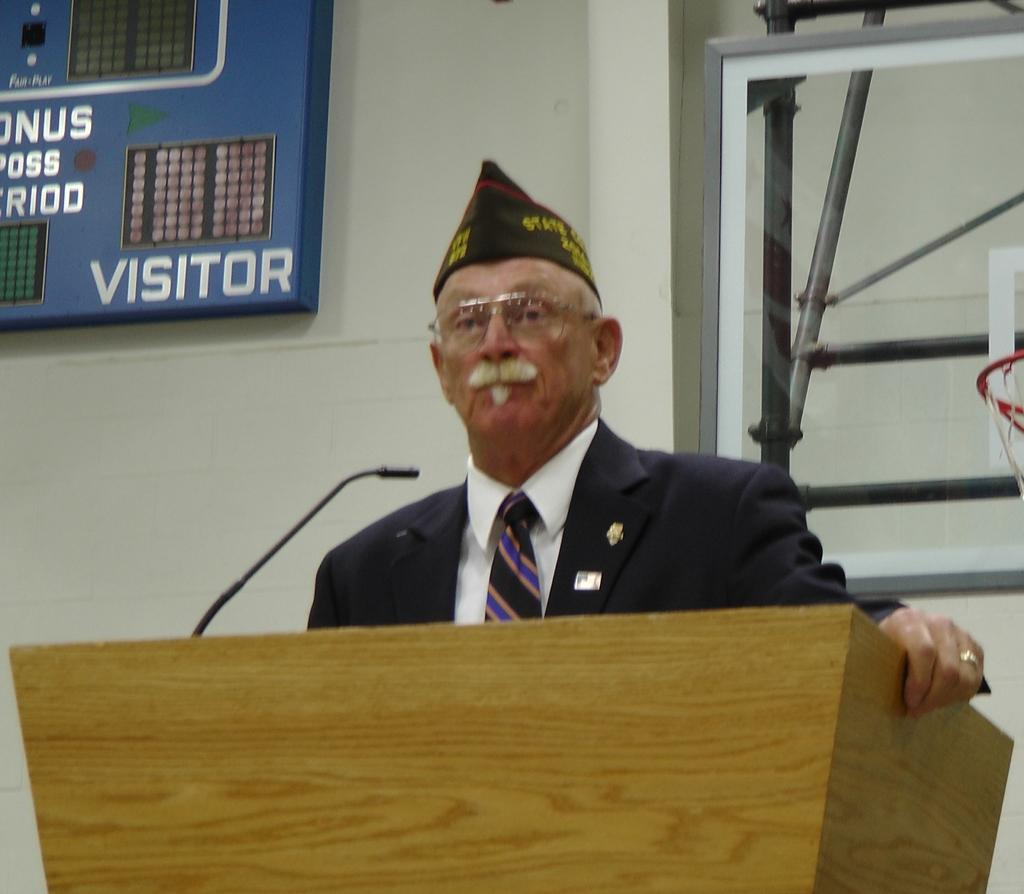What is the main subject of the image? There is a person in the image. What is the person holding in the image? The person is holding a podium. What is on the podium? There is a microphone on the podium. What can be seen in the background of the image? There is a wall in the background of the image. What type of jeans is the person wearing in the image? There is no information about the person's clothing in the image, so we cannot determine if they are wearing jeans or any other type of clothing. 